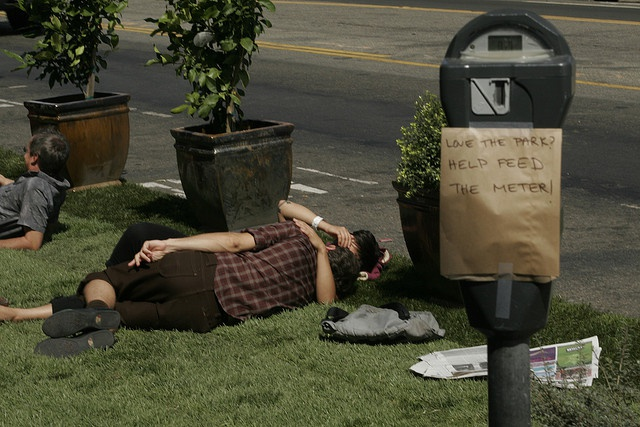Describe the objects in this image and their specific colors. I can see potted plant in black, gray, and darkgreen tones, people in black, maroon, and gray tones, parking meter in black and gray tones, potted plant in black, darkgreen, and gray tones, and potted plant in black, darkgreen, and gray tones in this image. 